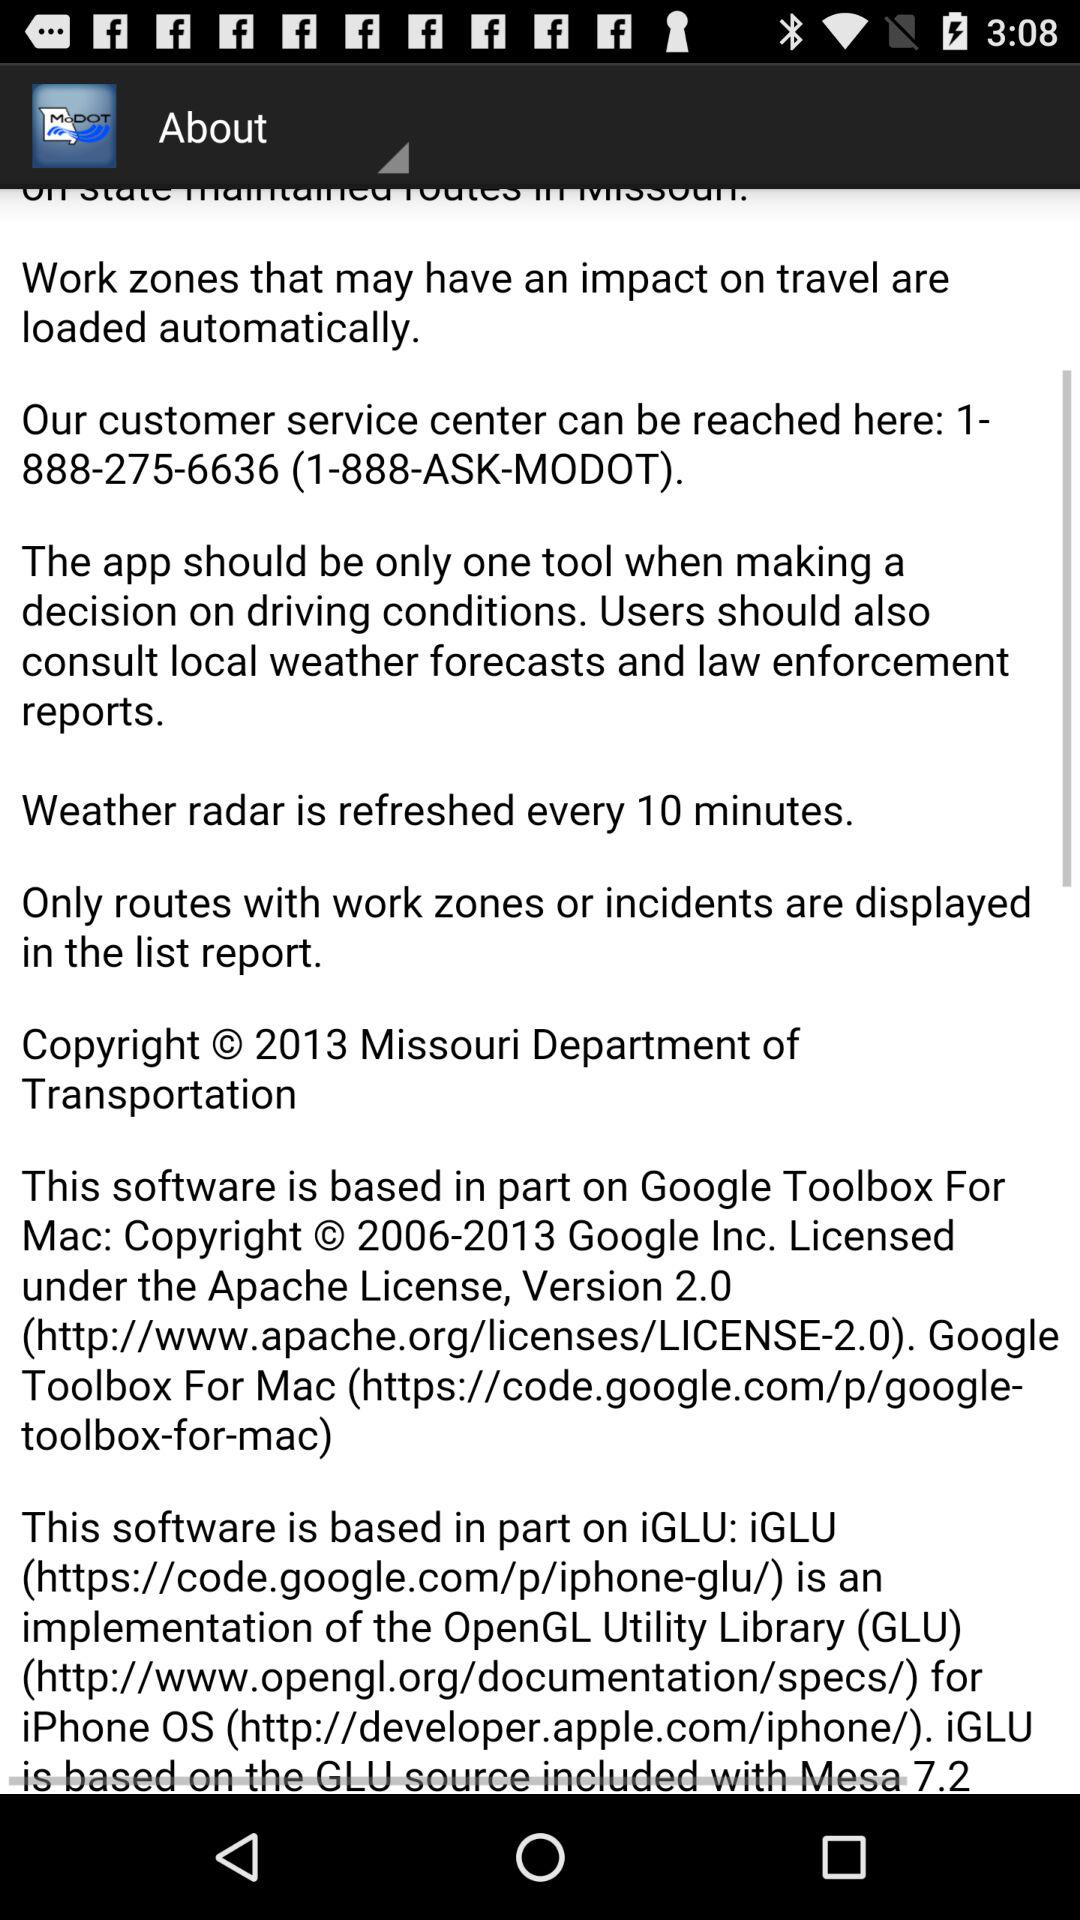What is the customer service contact number? The customer service contact number is 1-888-275-6636. 